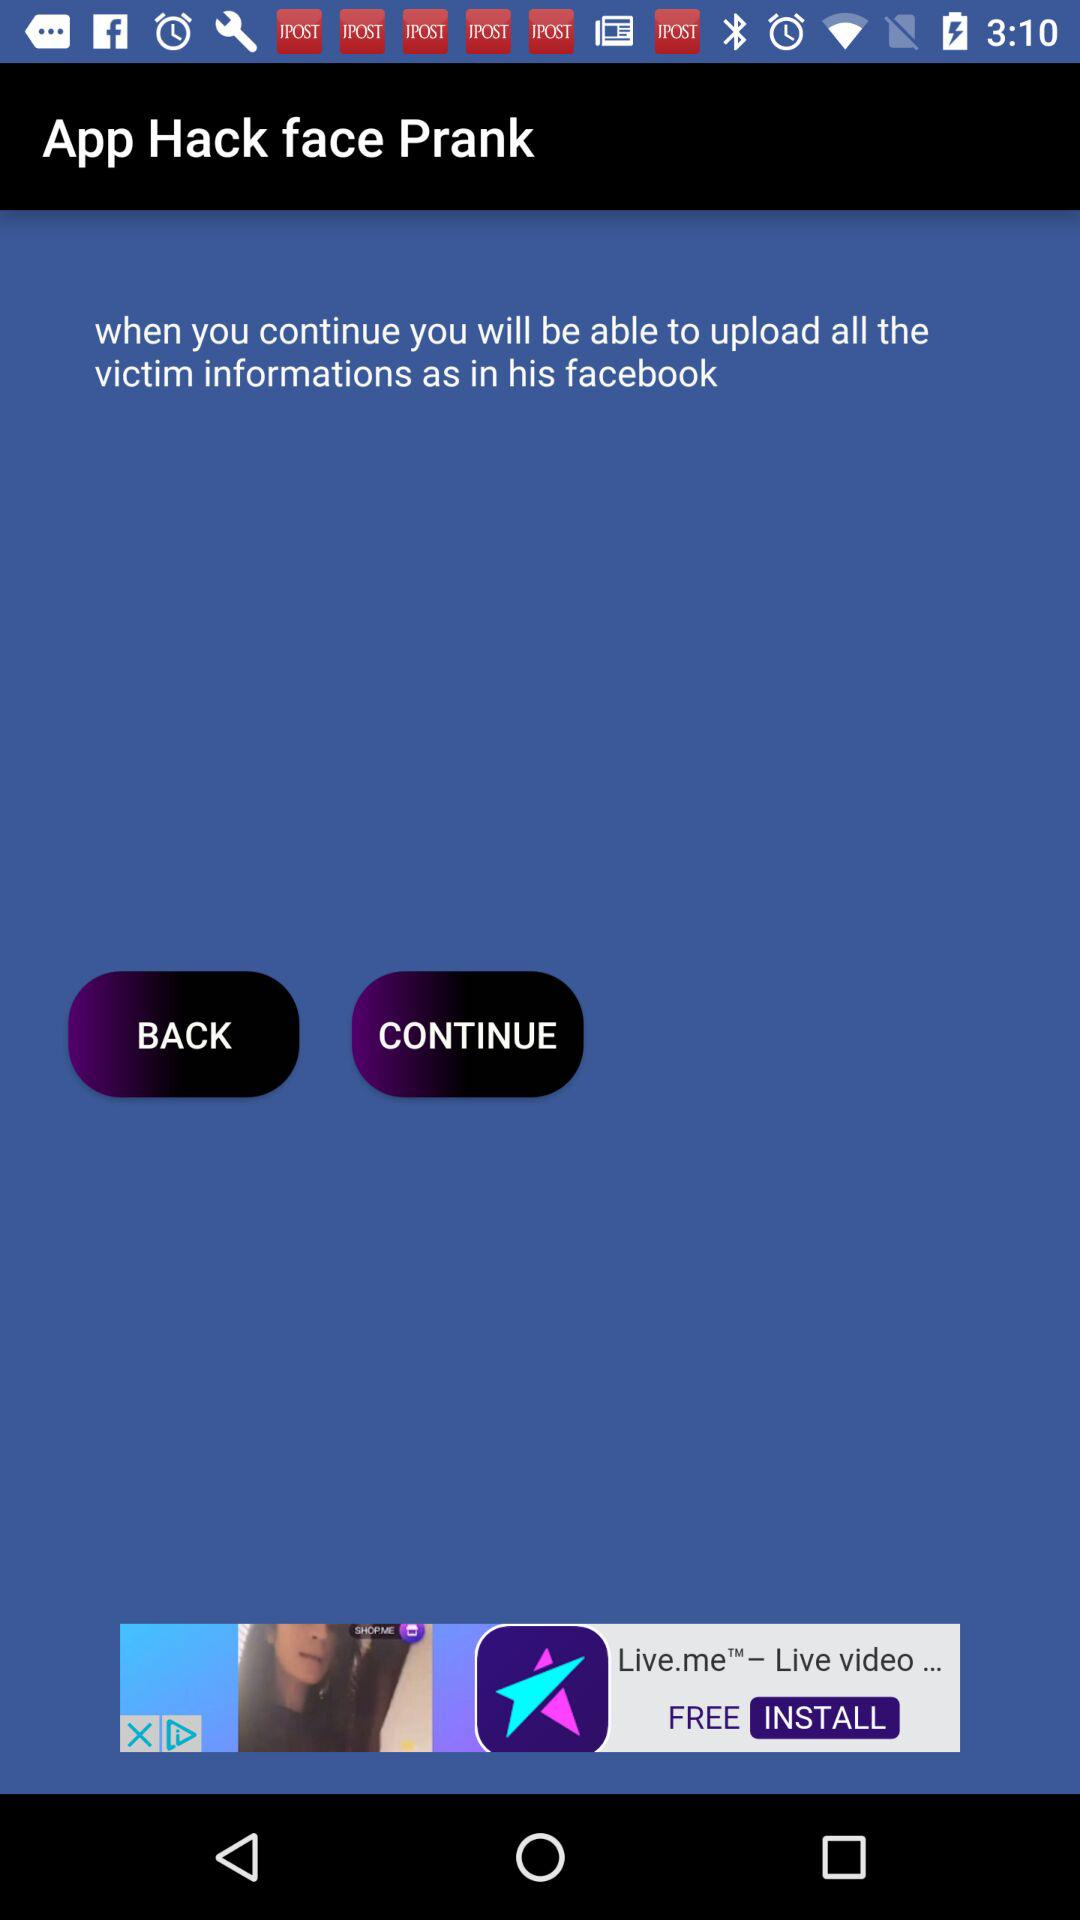What is the name of the application? The name of the application is "Hack face Prank". 